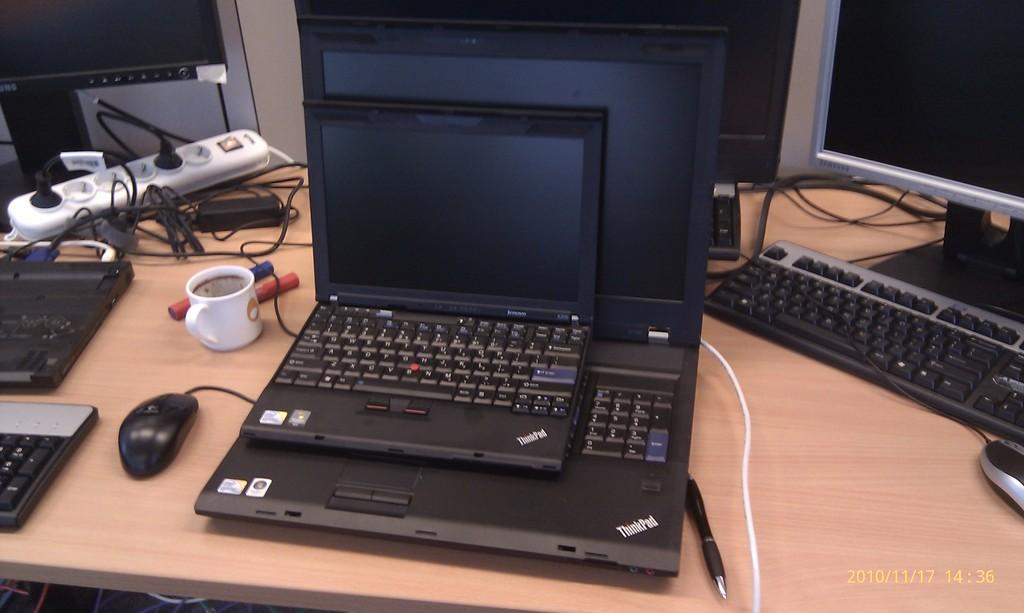<image>
Create a compact narrative representing the image presented. A smaller Thinkpad sits on top of a larger one, both open. 